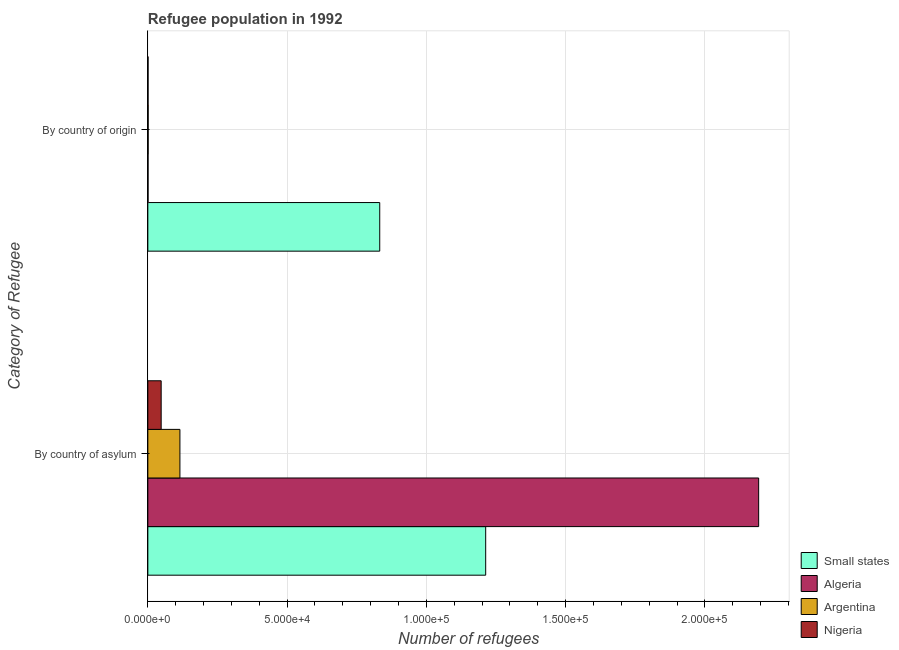How many different coloured bars are there?
Make the answer very short. 4. How many groups of bars are there?
Your response must be concise. 2. Are the number of bars per tick equal to the number of legend labels?
Provide a short and direct response. Yes. How many bars are there on the 1st tick from the top?
Give a very brief answer. 4. How many bars are there on the 2nd tick from the bottom?
Your response must be concise. 4. What is the label of the 2nd group of bars from the top?
Provide a succinct answer. By country of asylum. What is the number of refugees by country of origin in Small states?
Offer a terse response. 8.33e+04. Across all countries, what is the maximum number of refugees by country of asylum?
Offer a terse response. 2.19e+05. Across all countries, what is the minimum number of refugees by country of asylum?
Offer a terse response. 4782. In which country was the number of refugees by country of asylum maximum?
Make the answer very short. Algeria. In which country was the number of refugees by country of asylum minimum?
Keep it short and to the point. Nigeria. What is the total number of refugees by country of origin in the graph?
Offer a very short reply. 8.35e+04. What is the difference between the number of refugees by country of asylum in Nigeria and that in Small states?
Offer a terse response. -1.17e+05. What is the difference between the number of refugees by country of asylum in Nigeria and the number of refugees by country of origin in Small states?
Offer a very short reply. -7.85e+04. What is the average number of refugees by country of asylum per country?
Offer a terse response. 8.92e+04. What is the difference between the number of refugees by country of origin and number of refugees by country of asylum in Nigeria?
Provide a succinct answer. -4706. What is the ratio of the number of refugees by country of origin in Nigeria to that in Small states?
Provide a succinct answer. 0. Is the number of refugees by country of asylum in Small states less than that in Algeria?
Your answer should be very brief. Yes. What does the 4th bar from the top in By country of origin represents?
Your answer should be very brief. Small states. What does the 2nd bar from the bottom in By country of asylum represents?
Make the answer very short. Algeria. How many bars are there?
Offer a terse response. 8. Are all the bars in the graph horizontal?
Give a very brief answer. Yes. What is the difference between two consecutive major ticks on the X-axis?
Your response must be concise. 5.00e+04. Does the graph contain grids?
Make the answer very short. Yes. Where does the legend appear in the graph?
Provide a succinct answer. Bottom right. What is the title of the graph?
Provide a short and direct response. Refugee population in 1992. Does "Heavily indebted poor countries" appear as one of the legend labels in the graph?
Offer a very short reply. No. What is the label or title of the X-axis?
Your answer should be compact. Number of refugees. What is the label or title of the Y-axis?
Give a very brief answer. Category of Refugee. What is the Number of refugees in Small states in By country of asylum?
Make the answer very short. 1.21e+05. What is the Number of refugees in Algeria in By country of asylum?
Offer a very short reply. 2.19e+05. What is the Number of refugees in Argentina in By country of asylum?
Keep it short and to the point. 1.15e+04. What is the Number of refugees in Nigeria in By country of asylum?
Your answer should be very brief. 4782. What is the Number of refugees in Small states in By country of origin?
Ensure brevity in your answer.  8.33e+04. What is the Number of refugees in Argentina in By country of origin?
Provide a short and direct response. 113. Across all Category of Refugee, what is the maximum Number of refugees of Small states?
Your response must be concise. 1.21e+05. Across all Category of Refugee, what is the maximum Number of refugees of Algeria?
Keep it short and to the point. 2.19e+05. Across all Category of Refugee, what is the maximum Number of refugees of Argentina?
Your answer should be compact. 1.15e+04. Across all Category of Refugee, what is the maximum Number of refugees in Nigeria?
Your answer should be compact. 4782. Across all Category of Refugee, what is the minimum Number of refugees of Small states?
Offer a very short reply. 8.33e+04. Across all Category of Refugee, what is the minimum Number of refugees in Algeria?
Offer a very short reply. 71. Across all Category of Refugee, what is the minimum Number of refugees in Argentina?
Provide a succinct answer. 113. Across all Category of Refugee, what is the minimum Number of refugees of Nigeria?
Provide a succinct answer. 76. What is the total Number of refugees in Small states in the graph?
Ensure brevity in your answer.  2.05e+05. What is the total Number of refugees of Algeria in the graph?
Offer a terse response. 2.19e+05. What is the total Number of refugees in Argentina in the graph?
Offer a terse response. 1.16e+04. What is the total Number of refugees of Nigeria in the graph?
Offer a terse response. 4858. What is the difference between the Number of refugees in Small states in By country of asylum and that in By country of origin?
Ensure brevity in your answer.  3.80e+04. What is the difference between the Number of refugees of Algeria in By country of asylum and that in By country of origin?
Offer a terse response. 2.19e+05. What is the difference between the Number of refugees of Argentina in By country of asylum and that in By country of origin?
Your answer should be very brief. 1.14e+04. What is the difference between the Number of refugees in Nigeria in By country of asylum and that in By country of origin?
Ensure brevity in your answer.  4706. What is the difference between the Number of refugees in Small states in By country of asylum and the Number of refugees in Algeria in By country of origin?
Offer a terse response. 1.21e+05. What is the difference between the Number of refugees in Small states in By country of asylum and the Number of refugees in Argentina in By country of origin?
Provide a short and direct response. 1.21e+05. What is the difference between the Number of refugees of Small states in By country of asylum and the Number of refugees of Nigeria in By country of origin?
Your answer should be very brief. 1.21e+05. What is the difference between the Number of refugees of Algeria in By country of asylum and the Number of refugees of Argentina in By country of origin?
Provide a short and direct response. 2.19e+05. What is the difference between the Number of refugees in Algeria in By country of asylum and the Number of refugees in Nigeria in By country of origin?
Your answer should be very brief. 2.19e+05. What is the difference between the Number of refugees in Argentina in By country of asylum and the Number of refugees in Nigeria in By country of origin?
Your response must be concise. 1.14e+04. What is the average Number of refugees in Small states per Category of Refugee?
Keep it short and to the point. 1.02e+05. What is the average Number of refugees in Algeria per Category of Refugee?
Your answer should be very brief. 1.10e+05. What is the average Number of refugees in Argentina per Category of Refugee?
Give a very brief answer. 5814. What is the average Number of refugees of Nigeria per Category of Refugee?
Provide a short and direct response. 2429. What is the difference between the Number of refugees in Small states and Number of refugees in Algeria in By country of asylum?
Offer a terse response. -9.80e+04. What is the difference between the Number of refugees of Small states and Number of refugees of Argentina in By country of asylum?
Provide a succinct answer. 1.10e+05. What is the difference between the Number of refugees in Small states and Number of refugees in Nigeria in By country of asylum?
Your response must be concise. 1.17e+05. What is the difference between the Number of refugees of Algeria and Number of refugees of Argentina in By country of asylum?
Your answer should be very brief. 2.08e+05. What is the difference between the Number of refugees of Algeria and Number of refugees of Nigeria in By country of asylum?
Offer a terse response. 2.15e+05. What is the difference between the Number of refugees in Argentina and Number of refugees in Nigeria in By country of asylum?
Provide a succinct answer. 6733. What is the difference between the Number of refugees in Small states and Number of refugees in Algeria in By country of origin?
Keep it short and to the point. 8.32e+04. What is the difference between the Number of refugees of Small states and Number of refugees of Argentina in By country of origin?
Your response must be concise. 8.31e+04. What is the difference between the Number of refugees in Small states and Number of refugees in Nigeria in By country of origin?
Your answer should be compact. 8.32e+04. What is the difference between the Number of refugees in Algeria and Number of refugees in Argentina in By country of origin?
Your answer should be very brief. -42. What is the difference between the Number of refugees of Argentina and Number of refugees of Nigeria in By country of origin?
Offer a very short reply. 37. What is the ratio of the Number of refugees in Small states in By country of asylum to that in By country of origin?
Your response must be concise. 1.46. What is the ratio of the Number of refugees in Algeria in By country of asylum to that in By country of origin?
Provide a short and direct response. 3088.93. What is the ratio of the Number of refugees of Argentina in By country of asylum to that in By country of origin?
Provide a short and direct response. 101.9. What is the ratio of the Number of refugees of Nigeria in By country of asylum to that in By country of origin?
Keep it short and to the point. 62.92. What is the difference between the highest and the second highest Number of refugees of Small states?
Your answer should be very brief. 3.80e+04. What is the difference between the highest and the second highest Number of refugees in Algeria?
Your answer should be compact. 2.19e+05. What is the difference between the highest and the second highest Number of refugees in Argentina?
Make the answer very short. 1.14e+04. What is the difference between the highest and the second highest Number of refugees in Nigeria?
Offer a very short reply. 4706. What is the difference between the highest and the lowest Number of refugees of Small states?
Ensure brevity in your answer.  3.80e+04. What is the difference between the highest and the lowest Number of refugees in Algeria?
Your answer should be very brief. 2.19e+05. What is the difference between the highest and the lowest Number of refugees of Argentina?
Keep it short and to the point. 1.14e+04. What is the difference between the highest and the lowest Number of refugees in Nigeria?
Make the answer very short. 4706. 